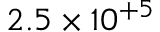<formula> <loc_0><loc_0><loc_500><loc_500>2 . 5 \times 1 0 ^ { + 5 }</formula> 